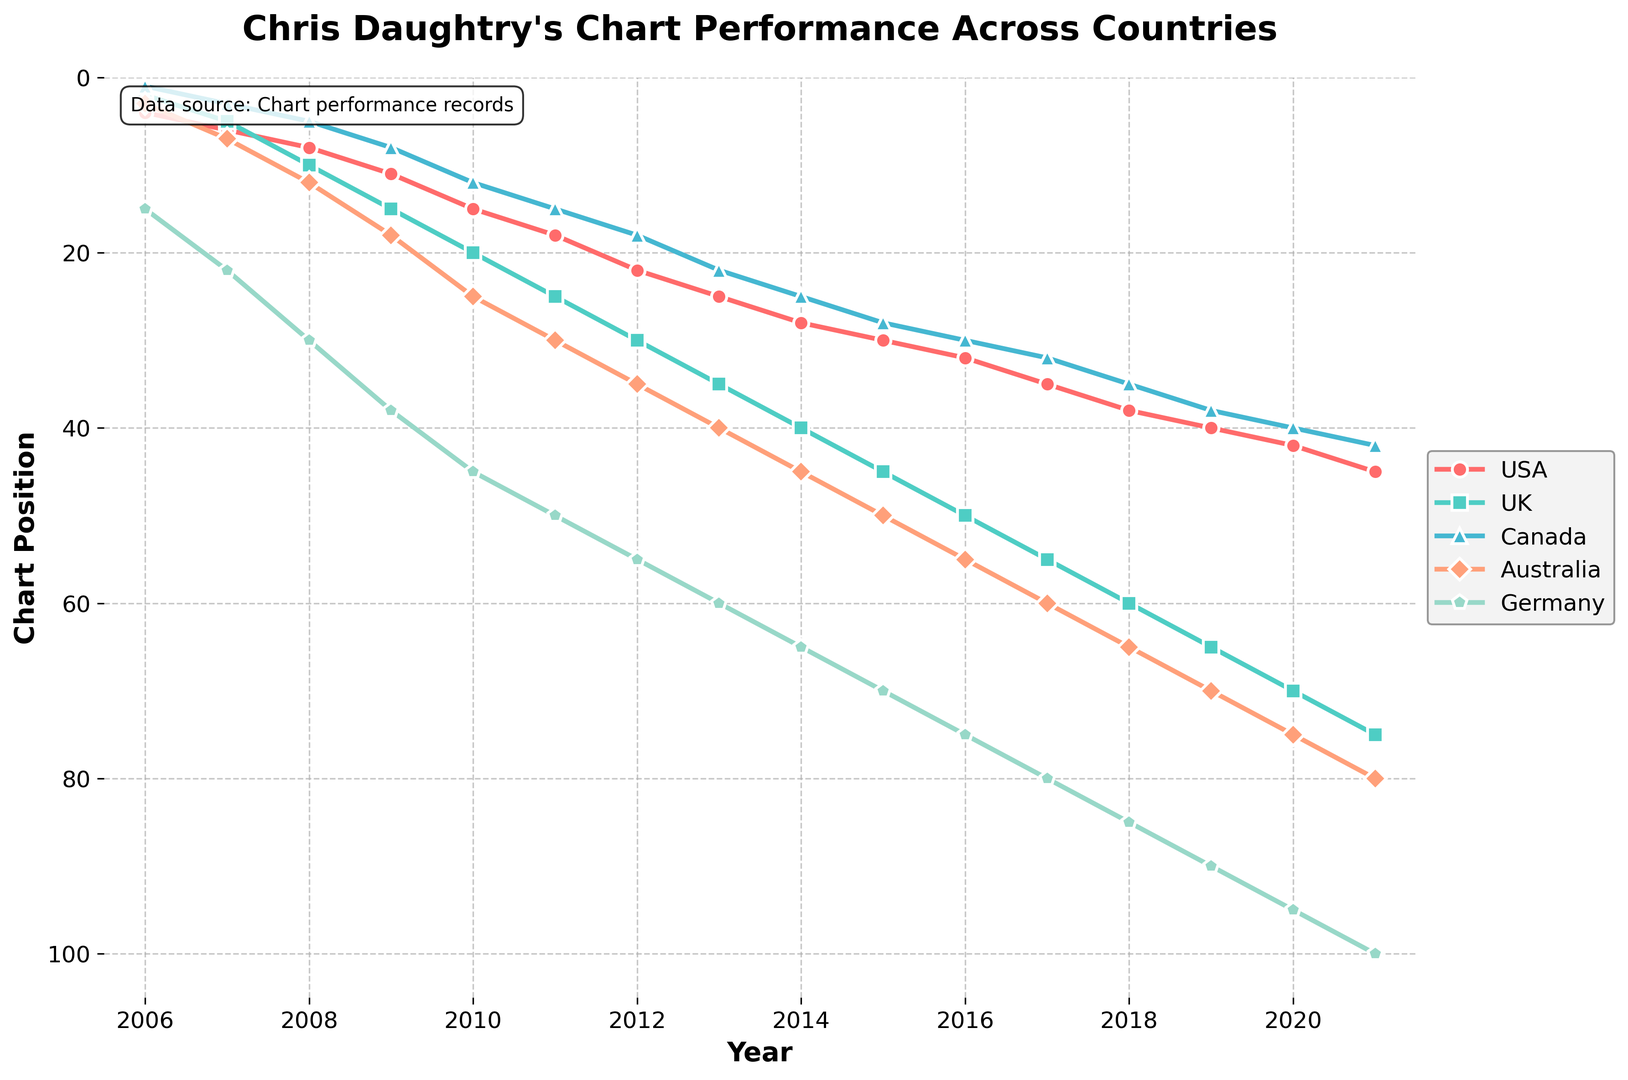Which year did Chris Daughtry's chart position in Canada surpass his position in the USA? We observe the plotted lines for USA and Canada from the start and see where the line for Canada (in blue) crosses above the line for the USA (in red). This occurs in 2016.
Answer: 2016 Between 2006 and 2021, in which country did Chris Daughtry's chart position decline the most rapidly? By comparing the slopes of the lines for each country, we notice the steepest negative slope (continuous increase in chart position, indicating worse performance) for Germany, marked in green.
Answer: Germany In which year did Chris Daughtry have his best chart position in Australia, and what was that position? By observing the lowest point on the line plotted for Australia (marked in light orange), we notice the best chart position was in 2006, with a position of 3.
Answer: 2006, 3 Which country consistently had the worst chart performance for Chris Daughtry from 2006 to 2021? By looking at the highest values on the y-axis over time, it is clear that Germany had the worst performance (highest chart positions) consistently.
Answer: Germany How many years did Chris Daughtry maintain a top-10 chart position in the UK? We examine the years where the UK's line stays below the y=10 mark. This happens in 2006 and 2007. Therefore, he maintained a top-10 chart position for 2 years in the UK.
Answer: 2 years What is the general trend of Chris Daughtry's chart performance in the USA from 2006 to 2021? Observing the line for USA, we see a general upward trend in chart positions (indicating worse performance over time).
Answer: Upward (declining performance) Which country shows the smallest range of chart positions for Chris Daughtry? By examining the range between the highest and lowest points of the lines, Australia (marked in light orange) shows a smaller range (3 to 75), as opposed to other countries with larger variations.
Answer: Australia What is the average chart position for Chris Daughtry in the UK over the entire period? Calculate the average using the given data: (2+5+10+15+20+25+30+35+40+45+50+55+60+65+70+75)/16 = 34.375, approximately 34.4.
Answer: 34.4 